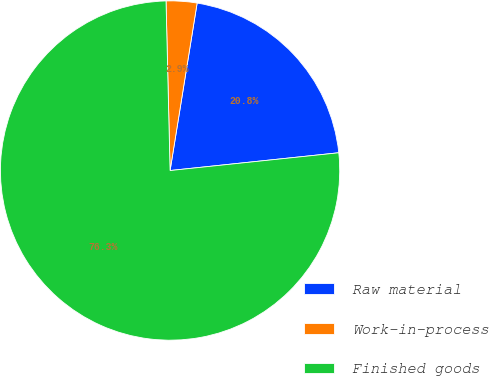Convert chart to OTSL. <chart><loc_0><loc_0><loc_500><loc_500><pie_chart><fcel>Raw material<fcel>Work-in-process<fcel>Finished goods<nl><fcel>20.78%<fcel>2.93%<fcel>76.29%<nl></chart> 